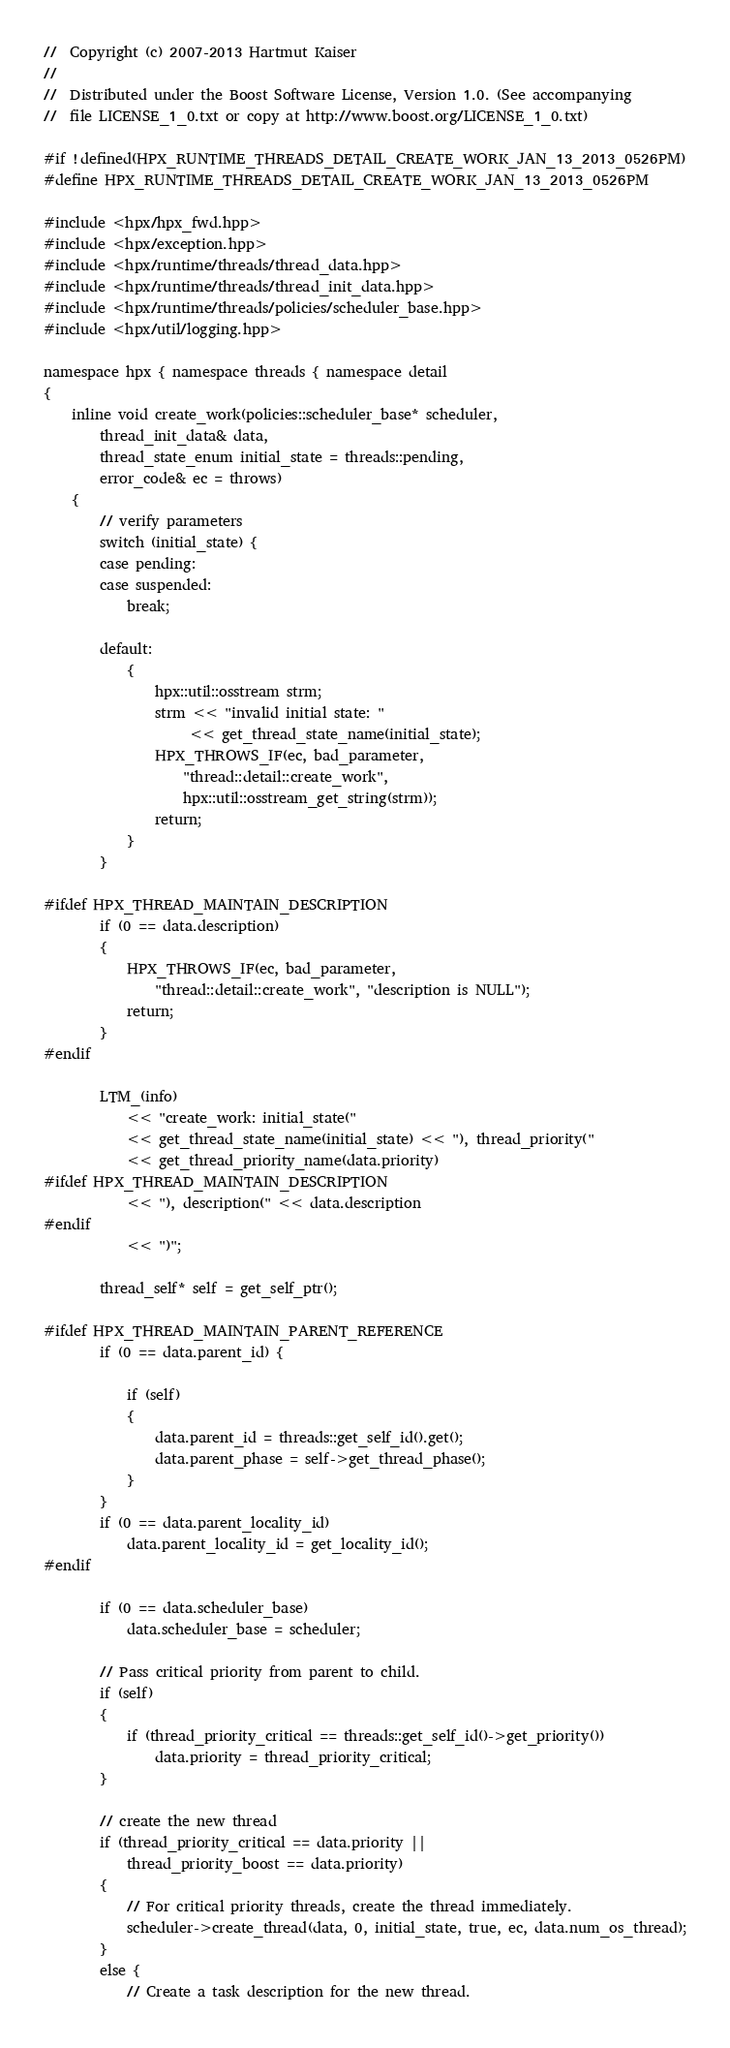Convert code to text. <code><loc_0><loc_0><loc_500><loc_500><_C++_>//  Copyright (c) 2007-2013 Hartmut Kaiser
//
//  Distributed under the Boost Software License, Version 1.0. (See accompanying
//  file LICENSE_1_0.txt or copy at http://www.boost.org/LICENSE_1_0.txt)

#if !defined(HPX_RUNTIME_THREADS_DETAIL_CREATE_WORK_JAN_13_2013_0526PM)
#define HPX_RUNTIME_THREADS_DETAIL_CREATE_WORK_JAN_13_2013_0526PM

#include <hpx/hpx_fwd.hpp>
#include <hpx/exception.hpp>
#include <hpx/runtime/threads/thread_data.hpp>
#include <hpx/runtime/threads/thread_init_data.hpp>
#include <hpx/runtime/threads/policies/scheduler_base.hpp>
#include <hpx/util/logging.hpp>

namespace hpx { namespace threads { namespace detail
{
    inline void create_work(policies::scheduler_base* scheduler,
        thread_init_data& data,
        thread_state_enum initial_state = threads::pending,
        error_code& ec = throws)
    {
        // verify parameters
        switch (initial_state) {
        case pending:
        case suspended:
            break;

        default:
            {
                hpx::util::osstream strm;
                strm << "invalid initial state: "
                     << get_thread_state_name(initial_state);
                HPX_THROWS_IF(ec, bad_parameter,
                    "thread::detail::create_work",
                    hpx::util::osstream_get_string(strm));
                return;
            }
        }

#ifdef HPX_THREAD_MAINTAIN_DESCRIPTION
        if (0 == data.description)
        {
            HPX_THROWS_IF(ec, bad_parameter,
                "thread::detail::create_work", "description is NULL");
            return;
        }
#endif

        LTM_(info)
            << "create_work: initial_state("
            << get_thread_state_name(initial_state) << "), thread_priority("
            << get_thread_priority_name(data.priority)
#ifdef HPX_THREAD_MAINTAIN_DESCRIPTION
            << "), description(" << data.description
#endif
            << ")";

        thread_self* self = get_self_ptr();

#ifdef HPX_THREAD_MAINTAIN_PARENT_REFERENCE
        if (0 == data.parent_id) {

            if (self)
            {
                data.parent_id = threads::get_self_id().get();
                data.parent_phase = self->get_thread_phase();
            }
        }
        if (0 == data.parent_locality_id)
            data.parent_locality_id = get_locality_id();
#endif

        if (0 == data.scheduler_base)
            data.scheduler_base = scheduler;

        // Pass critical priority from parent to child.
        if (self)
        {
            if (thread_priority_critical == threads::get_self_id()->get_priority())
                data.priority = thread_priority_critical;
        }

        // create the new thread
        if (thread_priority_critical == data.priority ||
            thread_priority_boost == data.priority)
        {
            // For critical priority threads, create the thread immediately.
            scheduler->create_thread(data, 0, initial_state, true, ec, data.num_os_thread);
        }
        else {
            // Create a task description for the new thread.</code> 